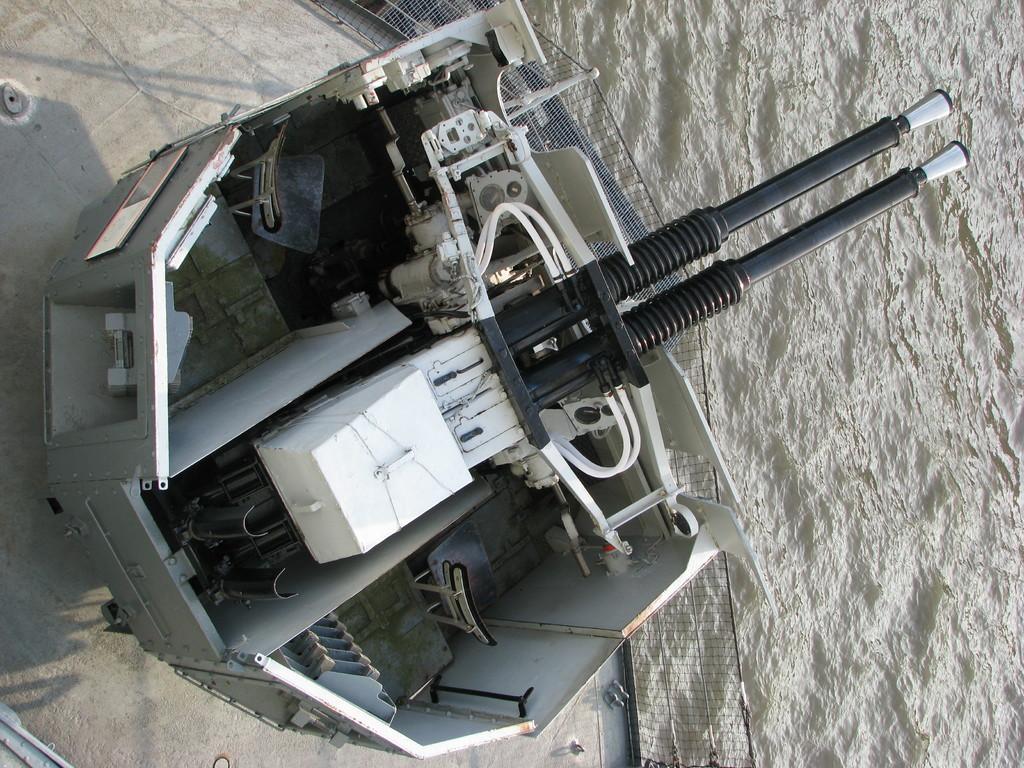Could you give a brief overview of what you see in this image? In this picture, we see a tanker with the rifle are placed in the water. On the right side, we see water and this water might be in the river. 